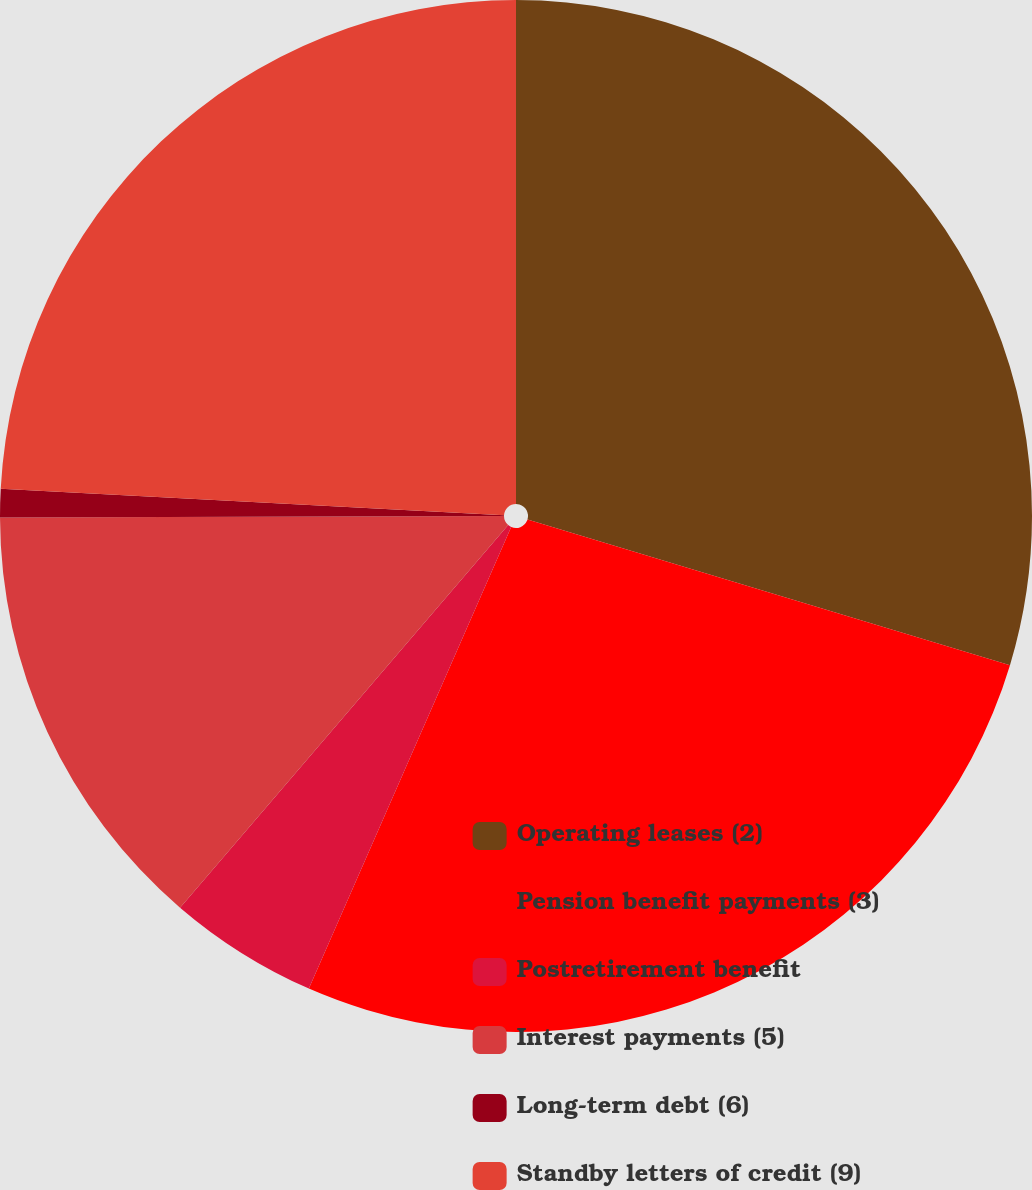Convert chart to OTSL. <chart><loc_0><loc_0><loc_500><loc_500><pie_chart><fcel>Operating leases (2)<fcel>Pension benefit payments (3)<fcel>Postretirement benefit<fcel>Interest payments (5)<fcel>Long-term debt (6)<fcel>Standby letters of credit (9)<nl><fcel>29.67%<fcel>26.91%<fcel>4.71%<fcel>13.67%<fcel>0.89%<fcel>24.16%<nl></chart> 